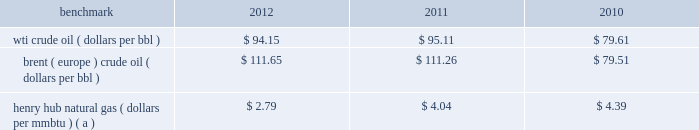Item 7 .
Management 2019s discussion and analysis of financial condition and results of operations we are an international energy company with operations in the u.s. , canada , africa , the middle east and europe .
Our operations are organized into three reportable segments : 2022 e&p which explores for , produces and markets liquid hydrocarbons and natural gas on a worldwide basis .
2022 osm which mines , extracts and transports bitumen from oil sands deposits in alberta , canada , and upgrades the bitumen to produce and market synthetic crude oil and vacuum gas oil .
2022 ig which produces and markets products manufactured from natural gas , such as lng and methanol , in e.g .
Certain sections of management 2019s discussion and analysis of financial condition and results of operations include forward- looking statements concerning trends or events potentially affecting our business .
These statements typically contain words such as "anticipates" "believes" "estimates" "expects" "targets" "plans" "projects" "could" "may" "should" "would" or similar words indicating that future outcomes are uncertain .
In accordance with "safe harbor" provisions of the private securities litigation reform act of 1995 , these statements are accompanied by cautionary language identifying important factors , though not necessarily all such factors , which could cause future outcomes to differ materially from those set forth in forward-looking statements .
For additional risk factors affecting our business , see item 1a .
Risk factors in this annual report on form 10-k .
Management 2019s discussion and analysis of financial condition and results of operations should be read in conjunction with the information under item 1 .
Business , item 1a .
Risk factors and item 8 .
Financial statements and supplementary data found in this annual report on form 10-k .
Spin-off downstream business on june 30 , 2011 , the spin-off of marathon 2019s downstream business was completed , creating two independent energy companies : marathon oil and mpc .
Marathon stockholders at the close of business on the record date of june 27 , 2011 received one share of mpc common stock for every two shares of marathon common stock held .
A private letter tax ruling received in june 2011 from the irs affirmed the tax-free nature of the spin-off .
Activities related to the downstream business have been treated as discontinued operations in 2011 and 2010 ( see item 8 .
Financial statements and supplementary data 2013 note 3 to the consolidated financial statements for additional information ) .
Overview 2013 market conditions exploration and production prevailing prices for the various grades of crude oil and natural gas that we produce significantly impact our revenues and cash flows .
The table lists benchmark crude oil and natural gas price annual averages for the past three years. .
Henry hub natural gas ( dollars per mmbtu ) ( a ) $ 2.79 $ 4.04 $ 4.39 ( a ) settlement date average .
Liquid hydrocarbon 2013 prices of crude oil have been volatile in recent years , but less so when comparing annual averages for 2012 and 2011 .
In 2011 , crude prices increased over 2010 levels , with increases in brent averages outstripping those in wti .
The quality , location and composition of our liquid hydrocarbon production mix will cause our u.s .
Liquid hydrocarbon realizations to differ from the wti benchmark .
In 2012 , 2011 and 2010 , the percentage of our u.s .
Crude oil and condensate production that was sour averaged 37 percent , 58 percent and 68 percent .
Sour crude contains more sulfur and tends to be heavier than light sweet crude oil so that refining it is more costly and produces lower value products ; therefore , sour crude is considered of lower quality and typically sells at a discount to wti .
The percentage of our u.s .
Crude and condensate production that is sour has been decreasing as onshore production from the eagle ford and bakken shale plays increases and production from the gulf of mexico declines .
In recent years , crude oil sold along the u.s .
Gulf coast has been priced at a premium to wti because the louisiana light sweet benchmark has been tracking brent , while production from inland areas farther from large refineries has been at a discount to wti .
Ngls were 10 percent , 7 percent and 6 percent of our u.s .
Liquid hydrocarbon sales in 2012 , 2011 and 2010 .
In 2012 , our sales of ngls increased due to our development of u.s .
Unconventional liquids-rich plays. .
By what percentage did the average price of wti crude oil increase from 2010 to 2012? 
Computations: ((94.15 - 79.61) / 79.61)
Answer: 0.18264. Item 7 .
Management 2019s discussion and analysis of financial condition and results of operations we are an international energy company with operations in the u.s. , canada , africa , the middle east and europe .
Our operations are organized into three reportable segments : 2022 e&p which explores for , produces and markets liquid hydrocarbons and natural gas on a worldwide basis .
2022 osm which mines , extracts and transports bitumen from oil sands deposits in alberta , canada , and upgrades the bitumen to produce and market synthetic crude oil and vacuum gas oil .
2022 ig which produces and markets products manufactured from natural gas , such as lng and methanol , in e.g .
Certain sections of management 2019s discussion and analysis of financial condition and results of operations include forward- looking statements concerning trends or events potentially affecting our business .
These statements typically contain words such as "anticipates" "believes" "estimates" "expects" "targets" "plans" "projects" "could" "may" "should" "would" or similar words indicating that future outcomes are uncertain .
In accordance with "safe harbor" provisions of the private securities litigation reform act of 1995 , these statements are accompanied by cautionary language identifying important factors , though not necessarily all such factors , which could cause future outcomes to differ materially from those set forth in forward-looking statements .
For additional risk factors affecting our business , see item 1a .
Risk factors in this annual report on form 10-k .
Management 2019s discussion and analysis of financial condition and results of operations should be read in conjunction with the information under item 1 .
Business , item 1a .
Risk factors and item 8 .
Financial statements and supplementary data found in this annual report on form 10-k .
Spin-off downstream business on june 30 , 2011 , the spin-off of marathon 2019s downstream business was completed , creating two independent energy companies : marathon oil and mpc .
Marathon stockholders at the close of business on the record date of june 27 , 2011 received one share of mpc common stock for every two shares of marathon common stock held .
A private letter tax ruling received in june 2011 from the irs affirmed the tax-free nature of the spin-off .
Activities related to the downstream business have been treated as discontinued operations in 2011 and 2010 ( see item 8 .
Financial statements and supplementary data 2013 note 3 to the consolidated financial statements for additional information ) .
Overview 2013 market conditions exploration and production prevailing prices for the various grades of crude oil and natural gas that we produce significantly impact our revenues and cash flows .
The table lists benchmark crude oil and natural gas price annual averages for the past three years. .
Henry hub natural gas ( dollars per mmbtu ) ( a ) $ 2.79 $ 4.04 $ 4.39 ( a ) settlement date average .
Liquid hydrocarbon 2013 prices of crude oil have been volatile in recent years , but less so when comparing annual averages for 2012 and 2011 .
In 2011 , crude prices increased over 2010 levels , with increases in brent averages outstripping those in wti .
The quality , location and composition of our liquid hydrocarbon production mix will cause our u.s .
Liquid hydrocarbon realizations to differ from the wti benchmark .
In 2012 , 2011 and 2010 , the percentage of our u.s .
Crude oil and condensate production that was sour averaged 37 percent , 58 percent and 68 percent .
Sour crude contains more sulfur and tends to be heavier than light sweet crude oil so that refining it is more costly and produces lower value products ; therefore , sour crude is considered of lower quality and typically sells at a discount to wti .
The percentage of our u.s .
Crude and condensate production that is sour has been decreasing as onshore production from the eagle ford and bakken shale plays increases and production from the gulf of mexico declines .
In recent years , crude oil sold along the u.s .
Gulf coast has been priced at a premium to wti because the louisiana light sweet benchmark has been tracking brent , while production from inland areas farther from large refineries has been at a discount to wti .
Ngls were 10 percent , 7 percent and 6 percent of our u.s .
Liquid hydrocarbon sales in 2012 , 2011 and 2010 .
In 2012 , our sales of ngls increased due to our development of u.s .
Unconventional liquids-rich plays. .
By what percentage did the average price of brent ( europe ) crude oil increase from 2010 to 2012? 
Computations: ((111.65 - 79.51) / 79.51)
Answer: 0.40423. 